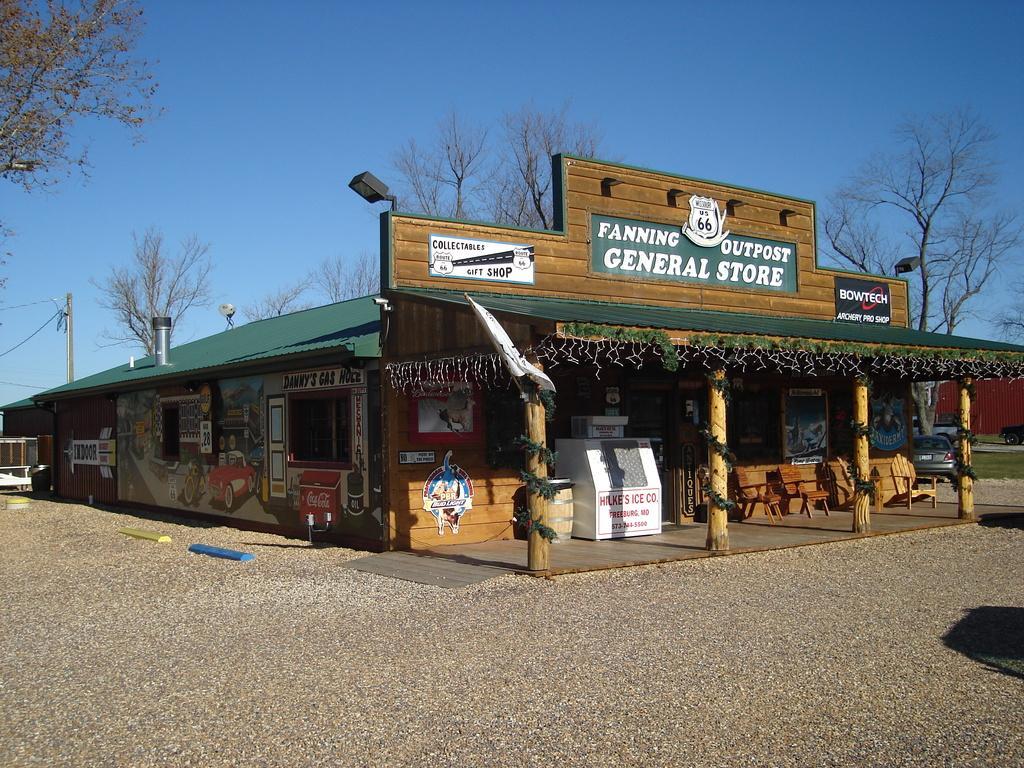In one or two sentences, can you explain what this image depicts? In this image there is a store, on top of the store there are lamps, metal pole and name boards, in front of the store there are some objects, chairs, display boards, posters and wooden pillars on the porch, beside the store there are cars parked and there is a metal shed wall, in the background of the image there are trees and electric poles with cables on it, in front of the store there is a road with some objects on it. 